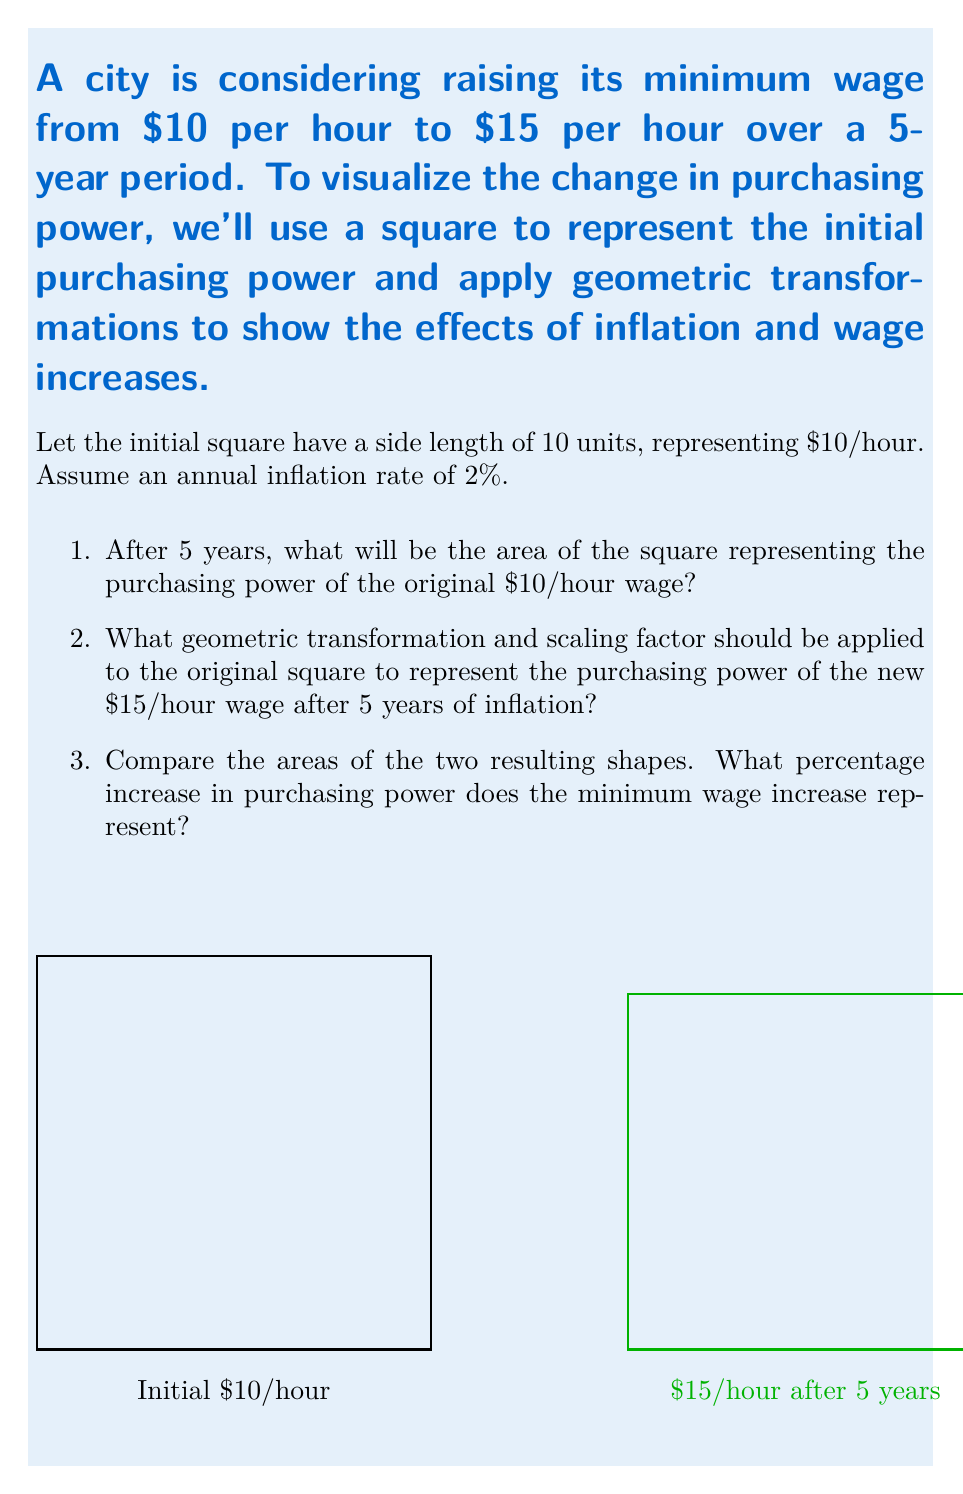Provide a solution to this math problem. Let's approach this problem step-by-step:

1. To calculate the effect of inflation on the original $10/hour wage:
   - After 5 years with 2% annual inflation, the value decreases by a factor of $(1-0.02)^5 = 0.9039$
   - The side length of the square after inflation: $10 * 0.9039 = 9.039$ units
   - The area of the square after inflation: $9.039^2 = 81.70$ square units

2. For the new $15/hour wage after 5 years of inflation:
   - The nominal increase is from $10 to $15, a factor of 1.5
   - We need to apply this scale factor and then account for inflation
   - Scale factor considering inflation: $1.5 * 0.9039 = 1.3559$
   - This means we need to scale the original square by a factor of 1.3559 in both dimensions

3. Comparing the areas:
   - Area of the square representing $15/hour after inflation: $(10 * 1.3559)^2 = 183.84$ square units
   - Original area: $10^2 = 100$ square units
   - Percentage increase: $\frac{183.84 - 100}{100} * 100\% = 83.84\%$

This analysis shows that while the nominal wage increase is 50%, the real increase in purchasing power after accounting for inflation is 83.84%. This challenges oversimplified arguments by demonstrating that the effects of minimum wage increases are more complex than simple percentages, involving factors like inflation over time.
Answer: 1. 81.70 square units
2. Scale by a factor of 1.3559 in both dimensions
3. 83.84% increase in purchasing power 